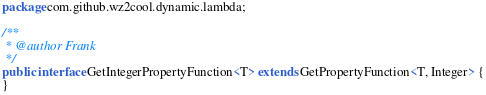Convert code to text. <code><loc_0><loc_0><loc_500><loc_500><_Java_>package com.github.wz2cool.dynamic.lambda;

/**
 * @author Frank
 */
public interface GetIntegerPropertyFunction<T> extends GetPropertyFunction<T, Integer> {
}
</code> 